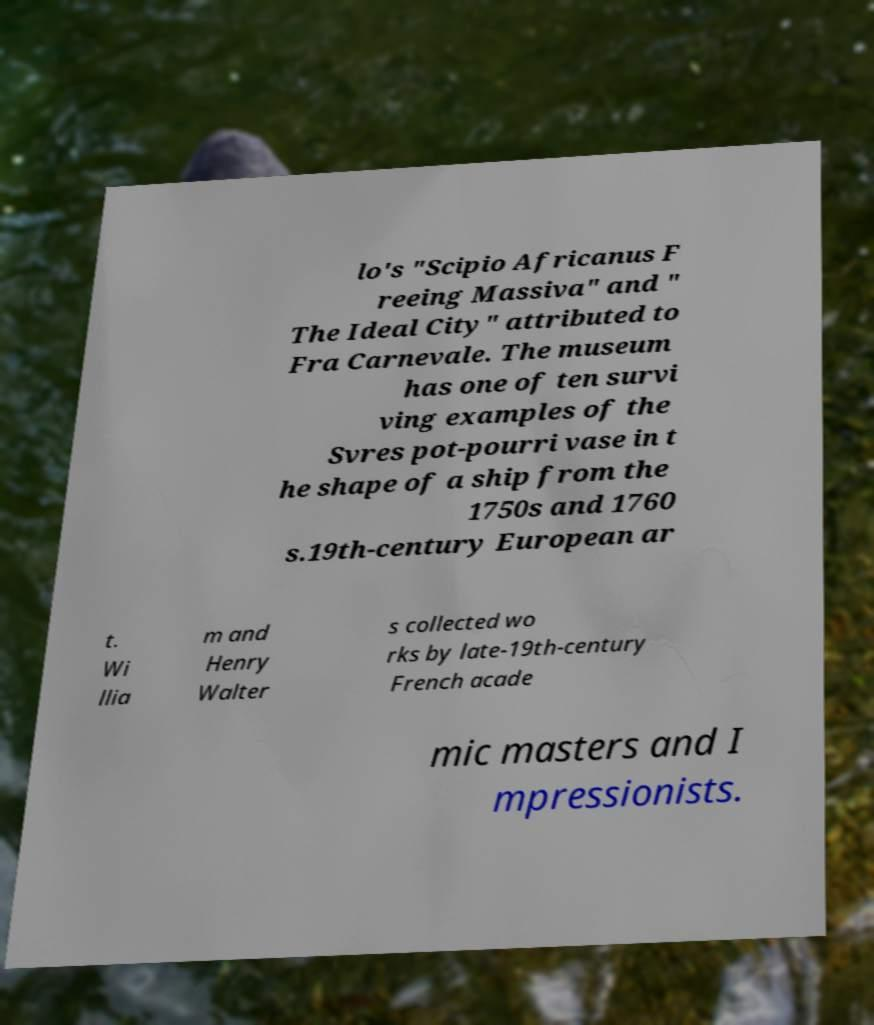Can you read and provide the text displayed in the image?This photo seems to have some interesting text. Can you extract and type it out for me? lo's "Scipio Africanus F reeing Massiva" and " The Ideal City" attributed to Fra Carnevale. The museum has one of ten survi ving examples of the Svres pot-pourri vase in t he shape of a ship from the 1750s and 1760 s.19th-century European ar t. Wi llia m and Henry Walter s collected wo rks by late-19th-century French acade mic masters and I mpressionists. 